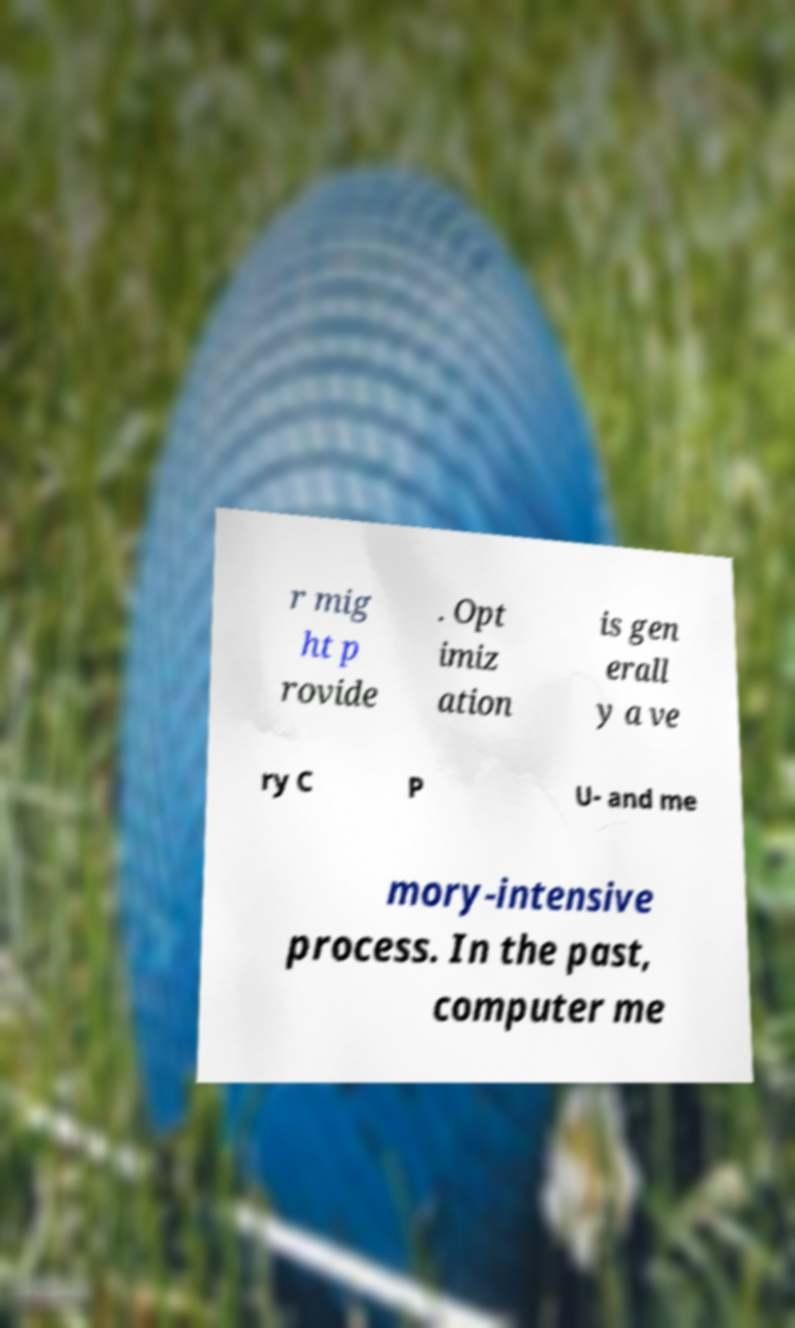For documentation purposes, I need the text within this image transcribed. Could you provide that? r mig ht p rovide . Opt imiz ation is gen erall y a ve ry C P U- and me mory-intensive process. In the past, computer me 